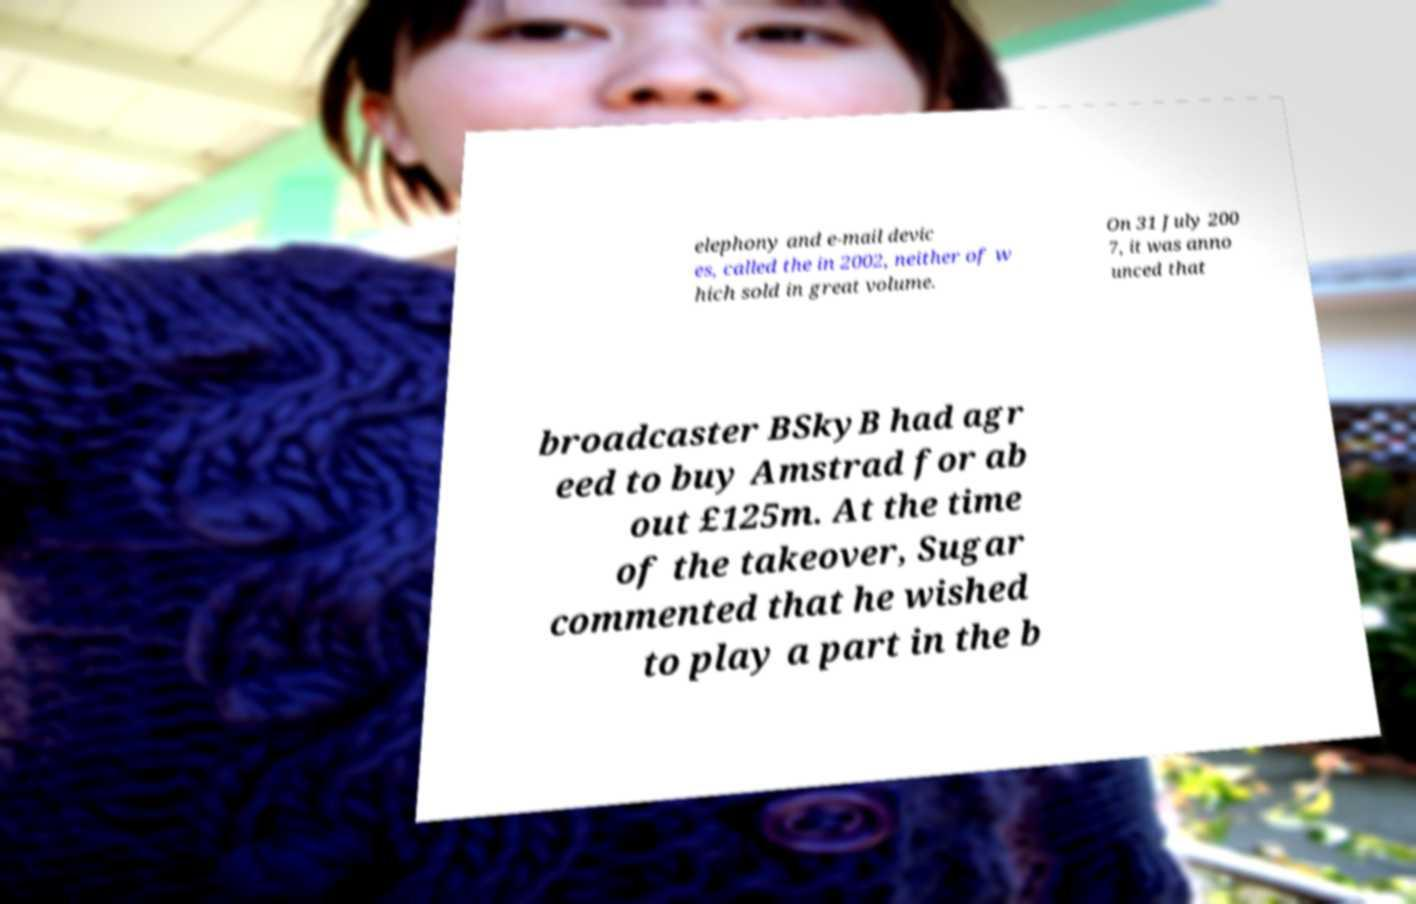What messages or text are displayed in this image? I need them in a readable, typed format. elephony and e-mail devic es, called the in 2002, neither of w hich sold in great volume. On 31 July 200 7, it was anno unced that broadcaster BSkyB had agr eed to buy Amstrad for ab out £125m. At the time of the takeover, Sugar commented that he wished to play a part in the b 